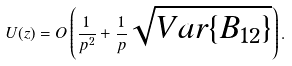Convert formula to latex. <formula><loc_0><loc_0><loc_500><loc_500>U ( z ) = O \left ( \frac { 1 } { p ^ { 2 } } + \frac { 1 } { p } \sqrt { { V a r } \{ B _ { 1 2 } \} } \right ) .</formula> 